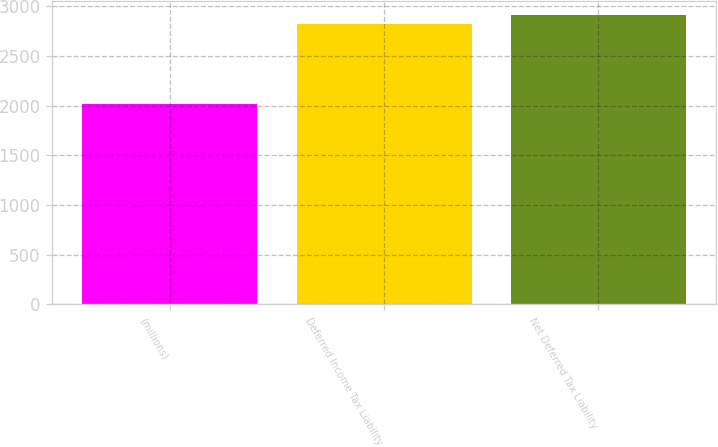<chart> <loc_0><loc_0><loc_500><loc_500><bar_chart><fcel>(millions)<fcel>Deferred Income Tax Liability<fcel>Net Deferred Tax Liability<nl><fcel>2015<fcel>2826<fcel>2907.1<nl></chart> 